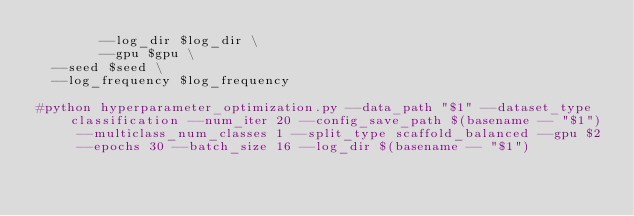<code> <loc_0><loc_0><loc_500><loc_500><_Bash_>        --log_dir $log_dir \
        --gpu $gpu \
	--seed $seed \
	--log_frequency $log_frequency

#python hyperparameter_optimization.py --data_path "$1" --dataset_type classification --num_iter 20 --config_save_path $(basename -- "$1") --multiclass_num_classes 1 --split_type scaffold_balanced --gpu $2 --epochs 30 --batch_size 16 --log_dir $(basename -- "$1")

</code> 